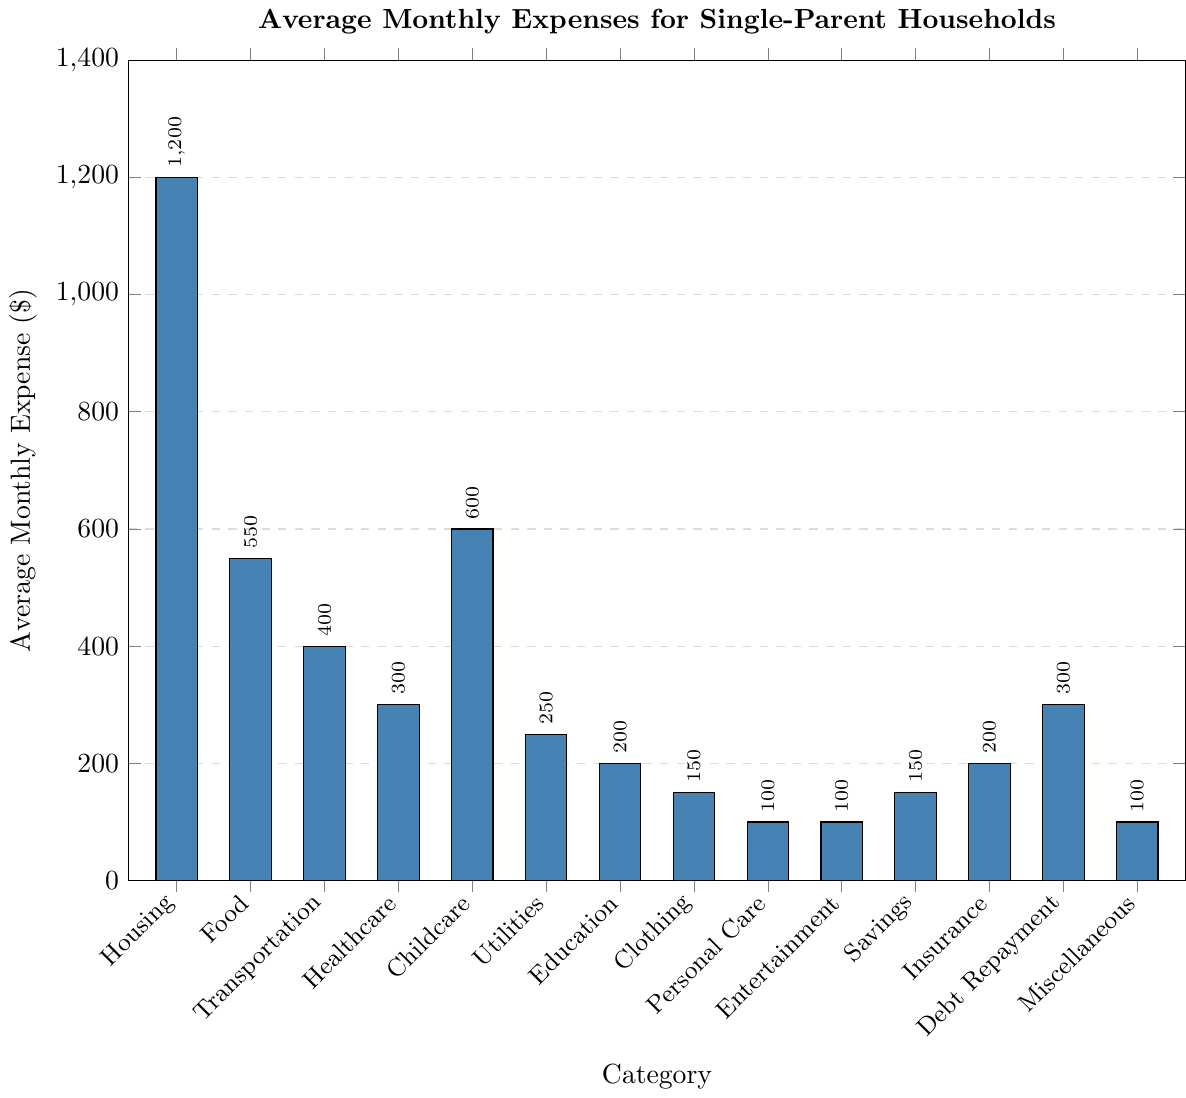Which category has the highest average monthly expense? The height of the bar for Housing is the tallest among all categories, indicating it has the highest average monthly expense.
Answer: Housing Which two categories have the same average monthly expense? By observing the bar heights and labels, Personal Care, Entertainment, and Miscellaneous all have bars of the same height representing an expense of $100 each.
Answer: Personal Care, Entertainment, Miscellaneous How much more is spent on Childcare compared to Transportation? The average monthly expense for Childcare is $600 and for Transportation is $400. Subtracting these gives $600 - $400 = $200.
Answer: $200 What is the total average monthly expense for Healthcare and Debt Repayment combined? The average monthly expense for Healthcare is $300, and for Debt Repayment is $300. Summing these gives $300 + $300 = $600.
Answer: $600 Which category has an average monthly expense that is $50 more than Utilities? The average monthly expense for Utilities is $250. Adding $50 gives $250 + $50 = $300, which is the expense for Healthcare and Debt Repayment.
Answer: Healthcare, Debt Repayment Is the average monthly expense for Childcare higher or lower than Food? The average monthly expense for Childcare is $600, while for Food it is $550. Therefore, Childcare is higher than Food.
Answer: Higher Which category has a lower average monthly expense, Education or Insurance? By comparing the bar heights, Education has an expense of $200, and Insurance has the same amount, $200. Therefore, both are equal.
Answer: Equal What is the sum of the average monthly expenses for categories with expenses $200 or less? The categories with expenses $200 or less are Education ($200), Clothing ($150), Personal Care ($100), Entertainment ($100), Savings ($150), and Miscellaneous ($100). Summing these gives $200 + $150 + $100 + $100 + $150 + $100 = $800.
Answer: $800 How does the average monthly expense for Transportation compare to that for Savings? The average monthly expense for Transportation is $400, while for Savings it is $150. Therefore, Transportation is greater than Savings.
Answer: Greater If the average monthly expense for Insurance increased by $50, what would the new total expense be? The current average monthly expense for Insurance is $200. Increasing it by $50 gives $200 + $50 = $250.
Answer: $250 